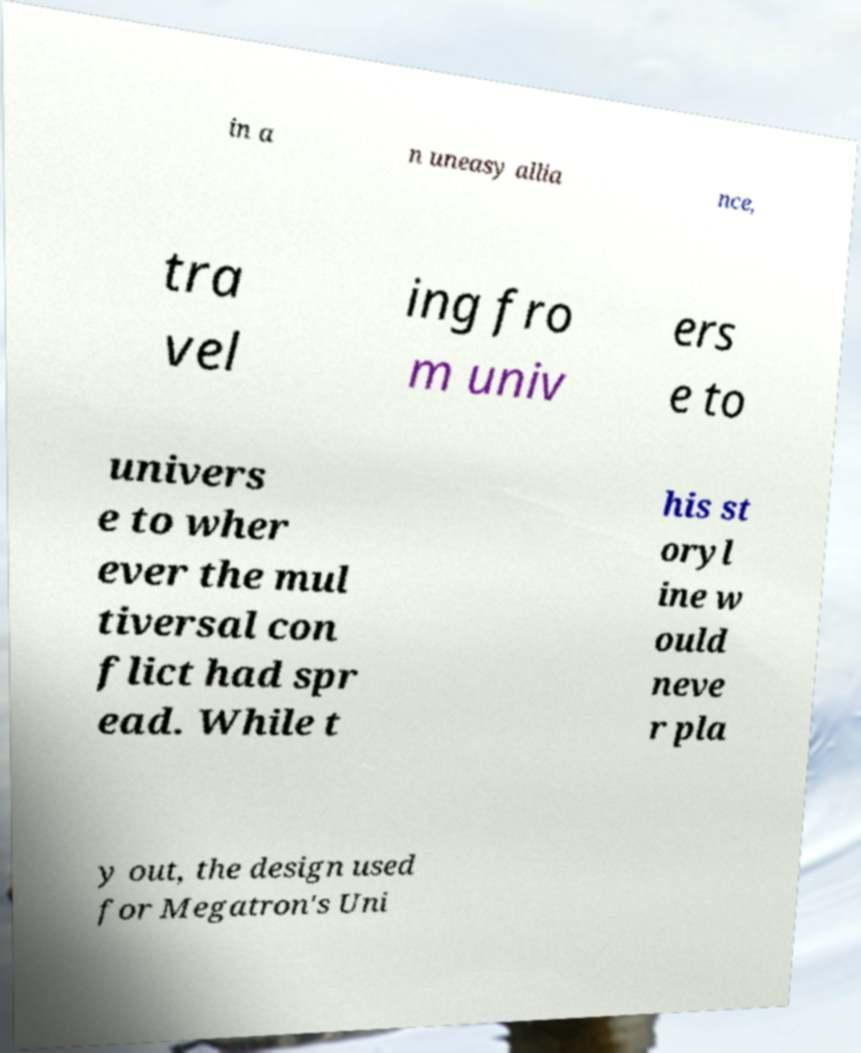I need the written content from this picture converted into text. Can you do that? in a n uneasy allia nce, tra vel ing fro m univ ers e to univers e to wher ever the mul tiversal con flict had spr ead. While t his st oryl ine w ould neve r pla y out, the design used for Megatron's Uni 